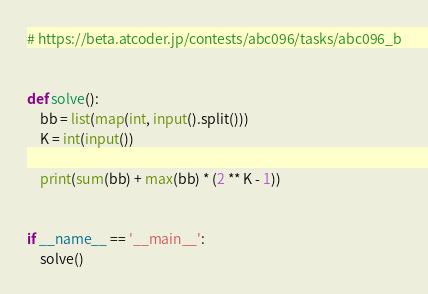Convert code to text. <code><loc_0><loc_0><loc_500><loc_500><_Python_># https://beta.atcoder.jp/contests/abc096/tasks/abc096_b


def solve():
    bb = list(map(int, input().split()))
    K = int(input())

    print(sum(bb) + max(bb) * (2 ** K - 1))


if __name__ == '__main__':
    solve()
</code> 